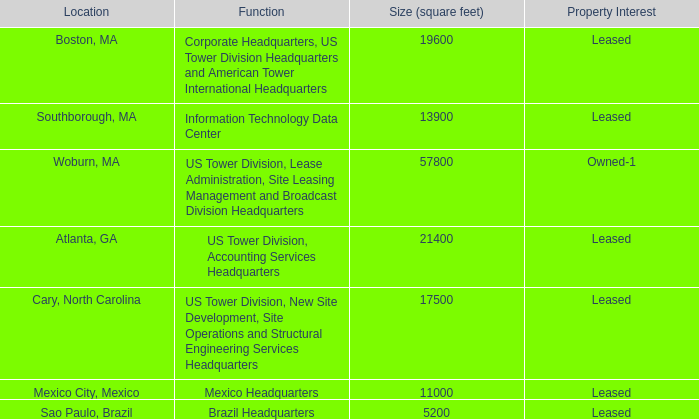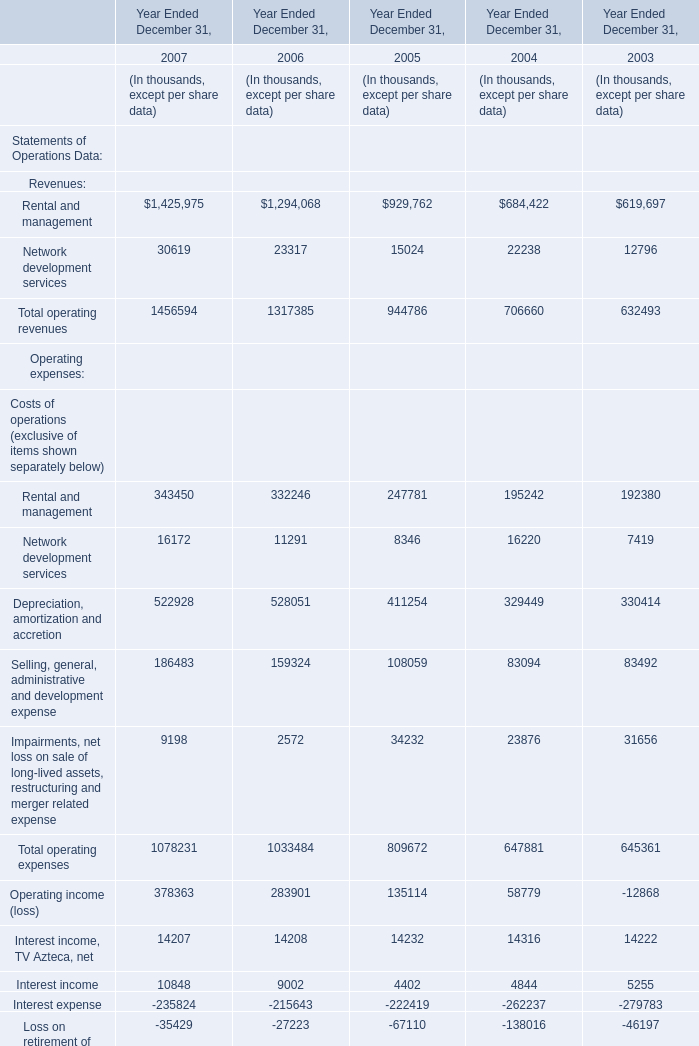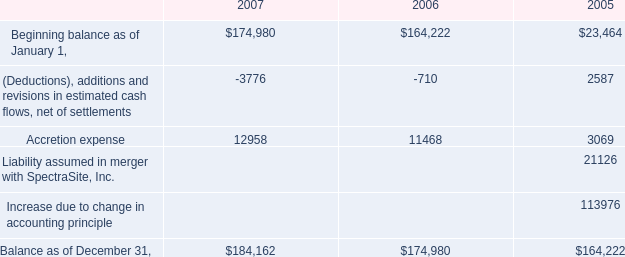What's the total amount of Rental and management Network development services Depreciation, amortization and accretion and Selling, general, administrative and development expense in 2007? (in thousand) 
Computations: (((343450 + 16172) + 522928) + 186483)
Answer: 1069033.0. 